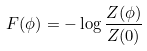<formula> <loc_0><loc_0><loc_500><loc_500>F ( \phi ) = - \log \frac { Z ( \phi ) } { Z ( 0 ) }</formula> 